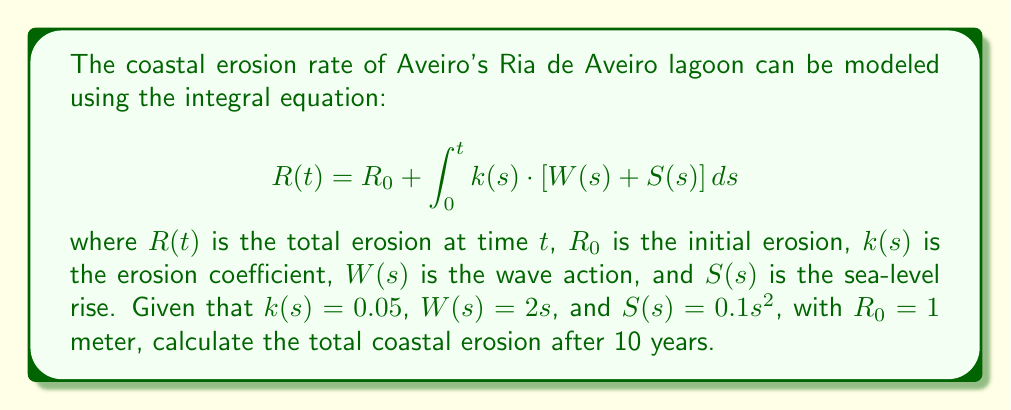Teach me how to tackle this problem. To solve this problem, we need to follow these steps:

1) First, let's substitute the given functions into the integral equation:

   $$R(10) = 1 + \int_0^{10} 0.05 \cdot (2s + 0.1s^2) \, ds$$

2) Simplify the integrand:

   $$R(10) = 1 + \int_0^{10} (0.1s + 0.005s^2) \, ds$$

3) Integrate the expression:

   $$R(10) = 1 + [0.05s^2 + \frac{0.005}{3}s^3]_0^{10}$$

4) Evaluate the integral at the limits:

   $$R(10) = 1 + [(0.05 \cdot 100 + \frac{0.005}{3} \cdot 1000) - (0 + 0)]$$

5) Calculate the result:

   $$R(10) = 1 + (5 + \frac{5}{3})$$
   $$R(10) = 1 + 5 + 1.67$$
   $$R(10) = 7.67$$

Therefore, the total coastal erosion after 10 years is approximately 7.67 meters.
Answer: 7.67 meters 